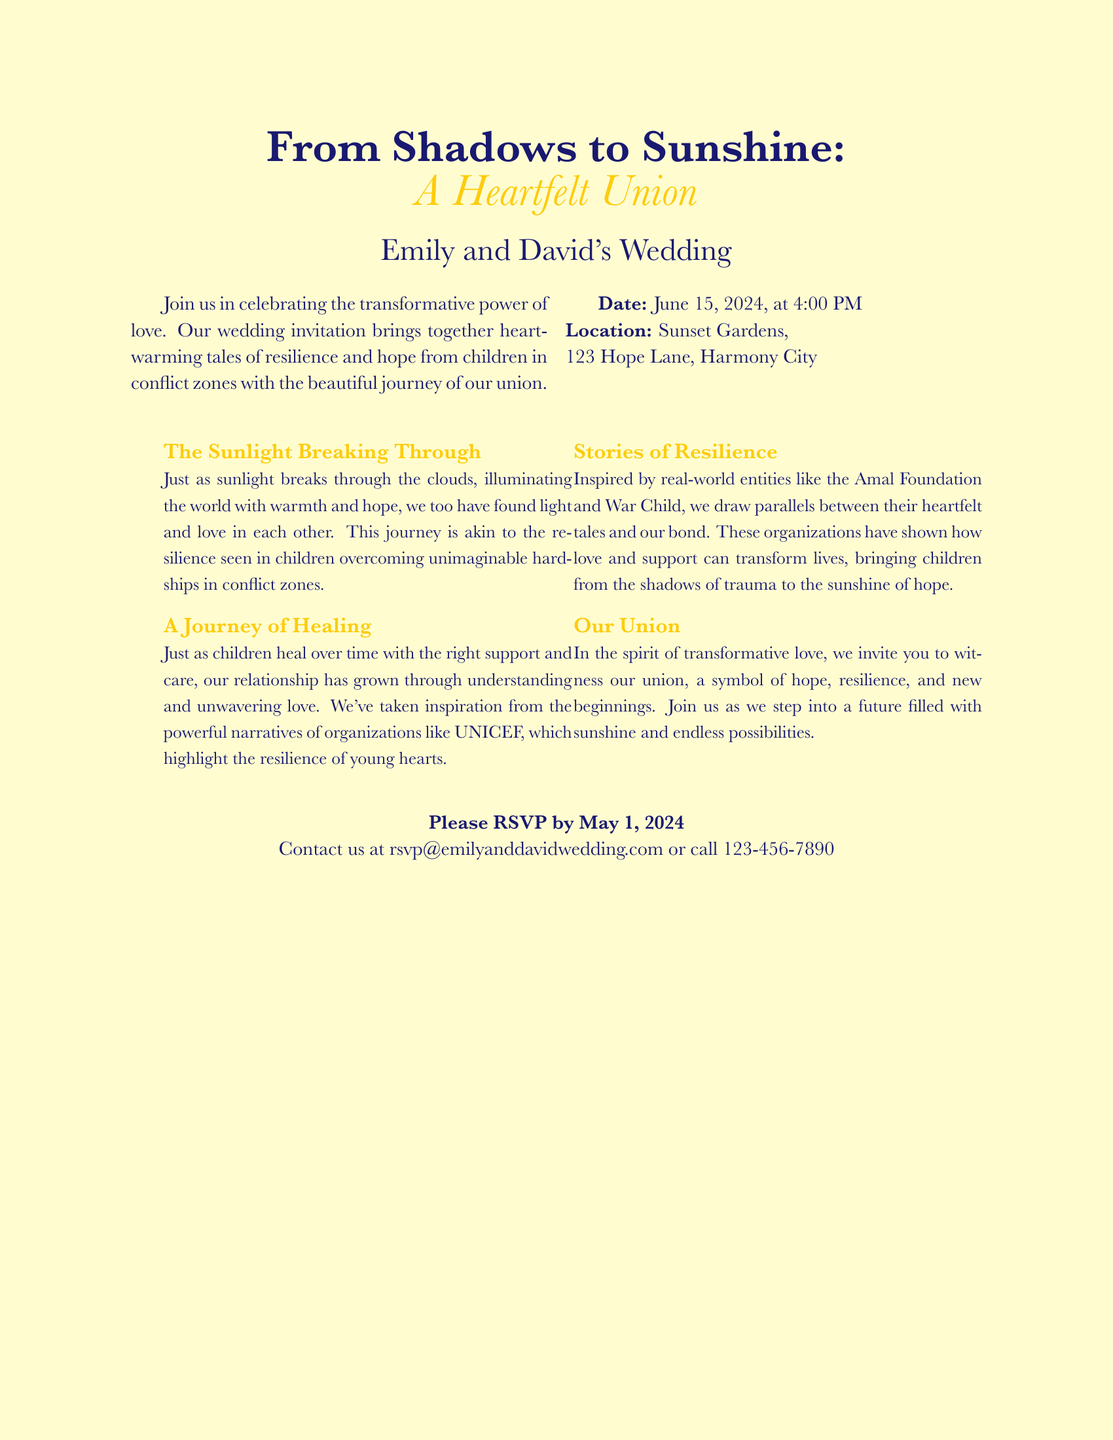What is the name of the couple getting married? The document states the couple's names in the title, which are "Emily and David."
Answer: Emily and David What is the date of the wedding? The date is mentioned explicitly in the document as "June 15, 2024."
Answer: June 15, 2024 What is the location of the wedding? The location is provided in the invitation, which is "Sunset Gardens, 123 Hope Lane, Harmony City."
Answer: Sunset Gardens, 123 Hope Lane, Harmony City What time is the wedding scheduled to begin? The wedding time is noted in the document as "4:00 PM."
Answer: 4:00 PM What metaphor is used to describe the couple's journey? The document mentions a metaphor comparing the couple's journey to "sunlight breaking through the clouds."
Answer: sunlight breaking through the clouds What organizations are mentioned as sources of inspiration? The document refers to organizations like "Amal Foundation" and "War Child."
Answer: Amal Foundation and War Child What is the RSVP deadline? The invitation states that RSVPs should be received by "May 1, 2024."
Answer: May 1, 2024 What theme is emphasized in this wedding invitation? The invitation emphasizes the "transformative power of love."
Answer: transformative power of love What type of document is this? The document is structured to invite guests to a wedding ceremony, making it a wedding invitation.
Answer: wedding invitation 